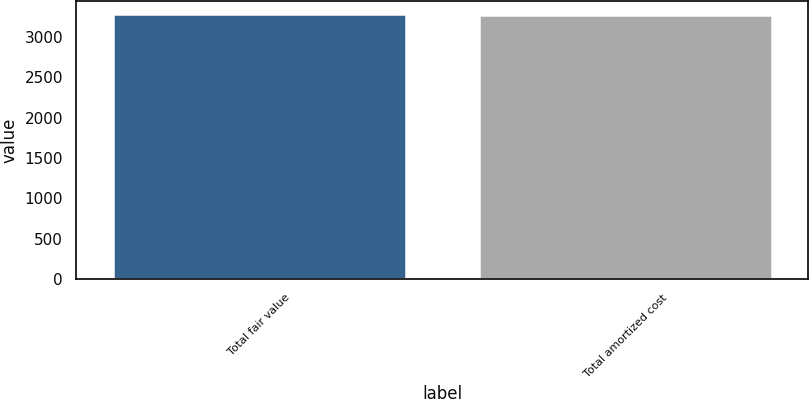Convert chart. <chart><loc_0><loc_0><loc_500><loc_500><bar_chart><fcel>Total fair value<fcel>Total amortized cost<nl><fcel>3274<fcel>3270<nl></chart> 